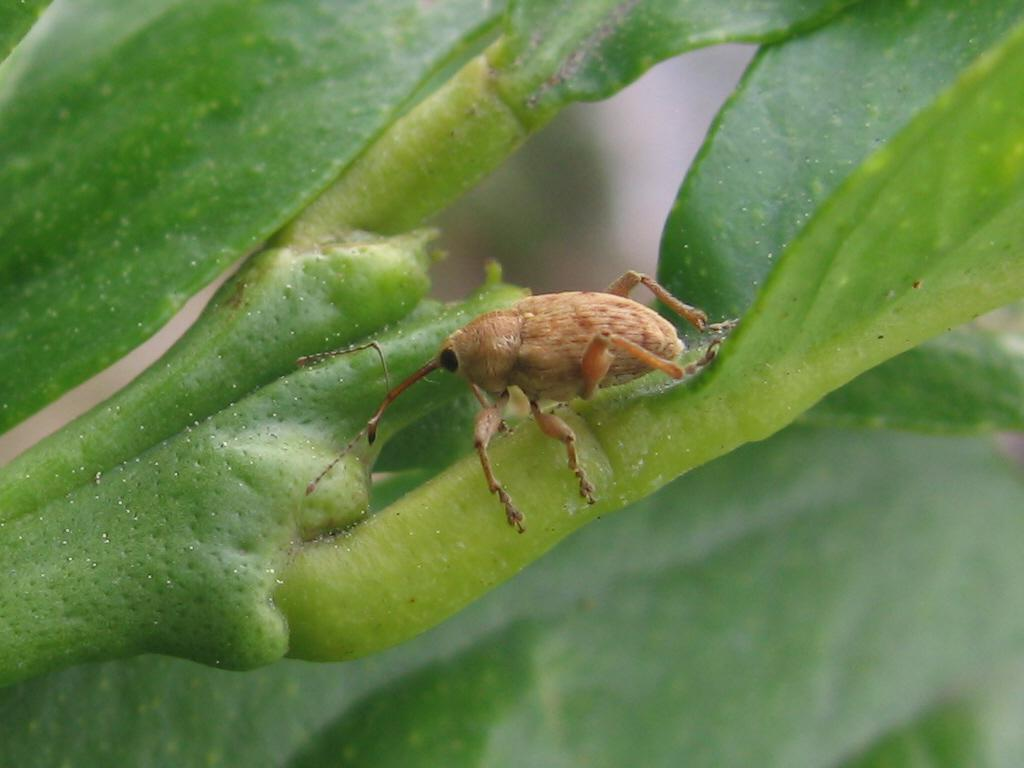What type of creature can be seen in the picture? There is a bug in the picture. What else is present in the image besides the bug? There is a stem of a plant in the picture. Can you describe the background of the image? The backdrop of the image is blurred. How much money is hidden in the bun in the image? There is no bun or money present in the image; it features a bug and a stem of a plant. 